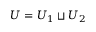Convert formula to latex. <formula><loc_0><loc_0><loc_500><loc_500>U = U _ { 1 } \sqcup U _ { 2 }</formula> 